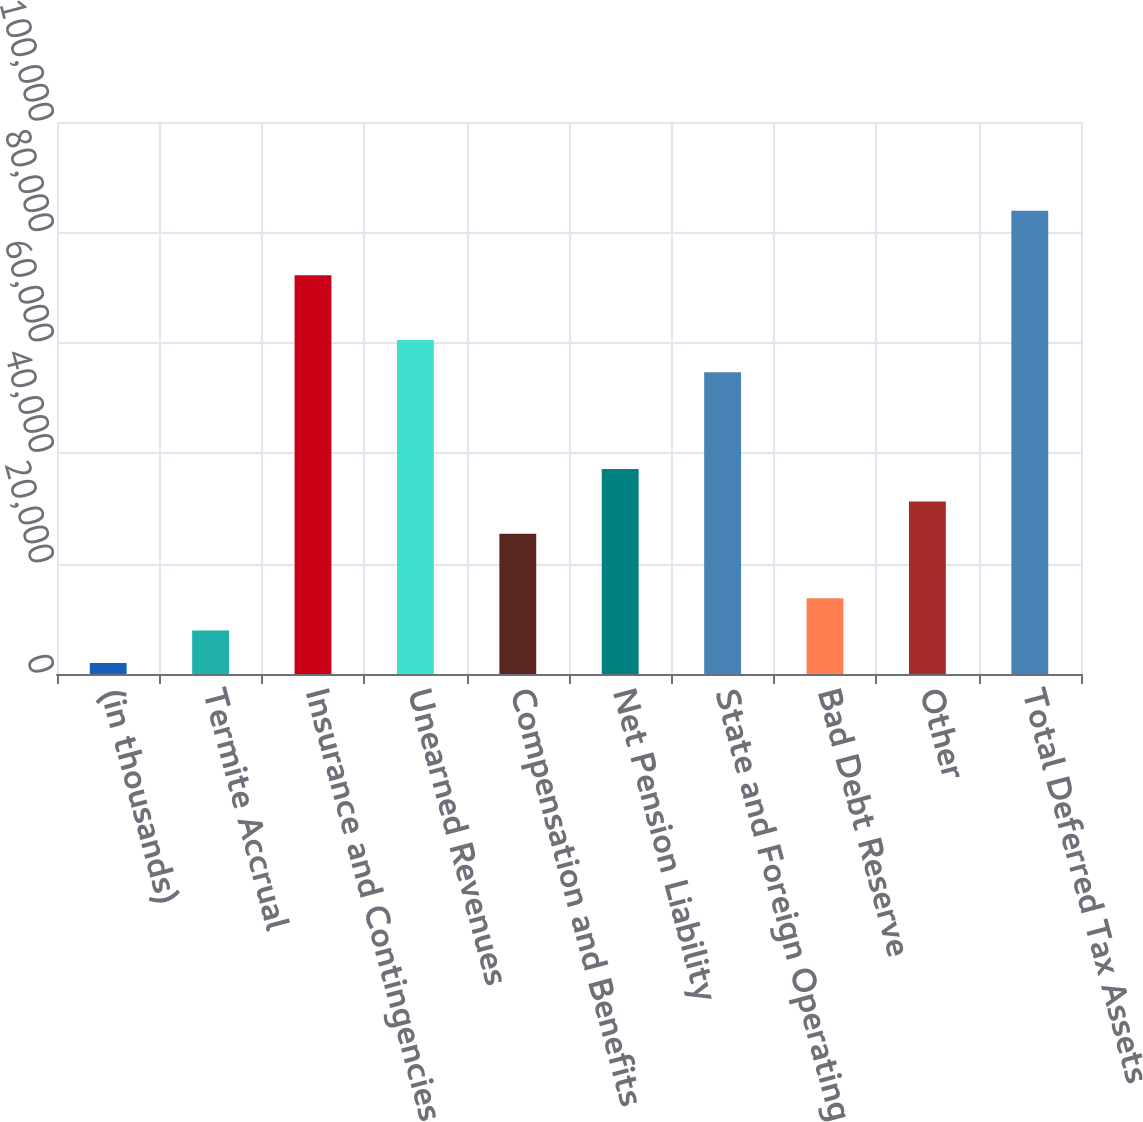Convert chart. <chart><loc_0><loc_0><loc_500><loc_500><bar_chart><fcel>(in thousands)<fcel>Termite Accrual<fcel>Insurance and Contingencies<fcel>Unearned Revenues<fcel>Compensation and Benefits<fcel>Net Pension Liability<fcel>State and Foreign Operating<fcel>Bad Debt Reserve<fcel>Other<fcel>Total Deferred Tax Assets<nl><fcel>2010<fcel>7861.4<fcel>72226.8<fcel>60524<fcel>25415.6<fcel>37118.4<fcel>54672.6<fcel>13712.8<fcel>31267<fcel>83929.6<nl></chart> 